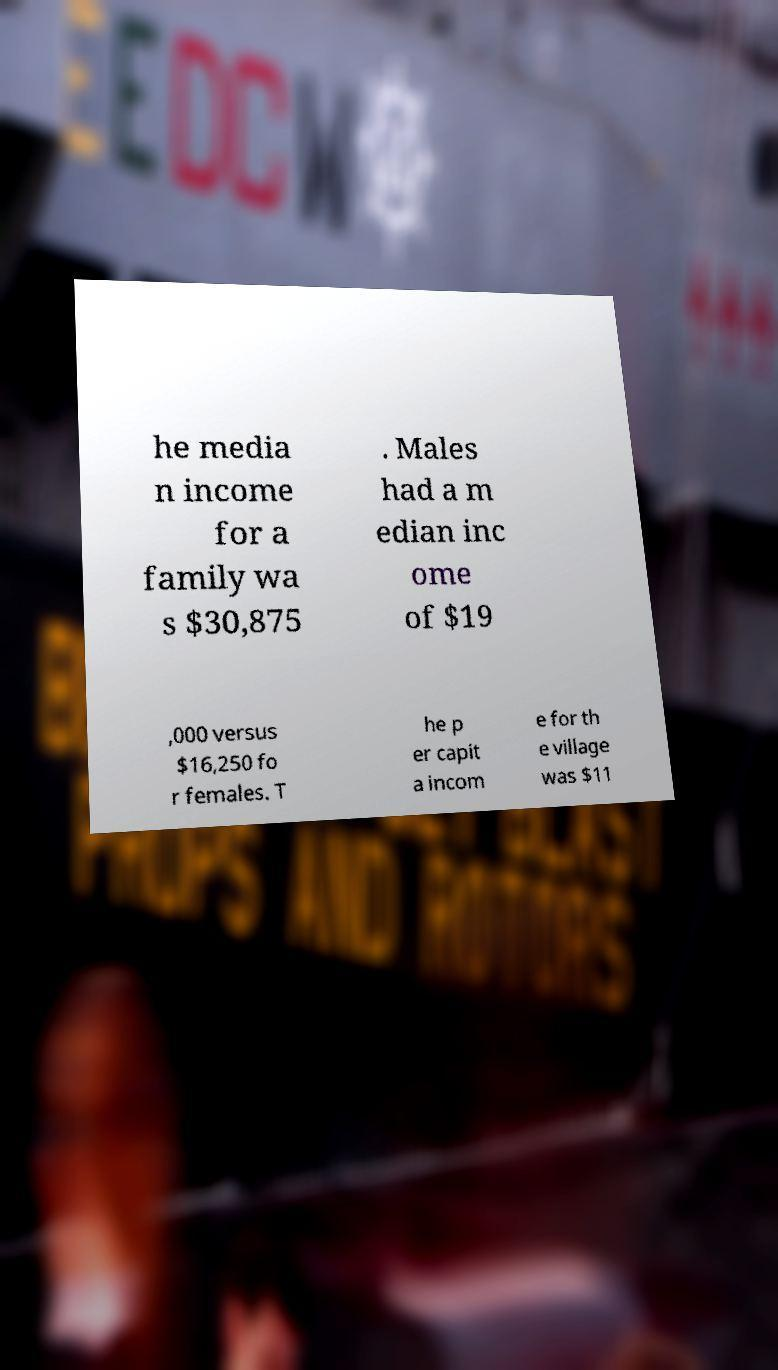For documentation purposes, I need the text within this image transcribed. Could you provide that? he media n income for a family wa s $30,875 . Males had a m edian inc ome of $19 ,000 versus $16,250 fo r females. T he p er capit a incom e for th e village was $11 